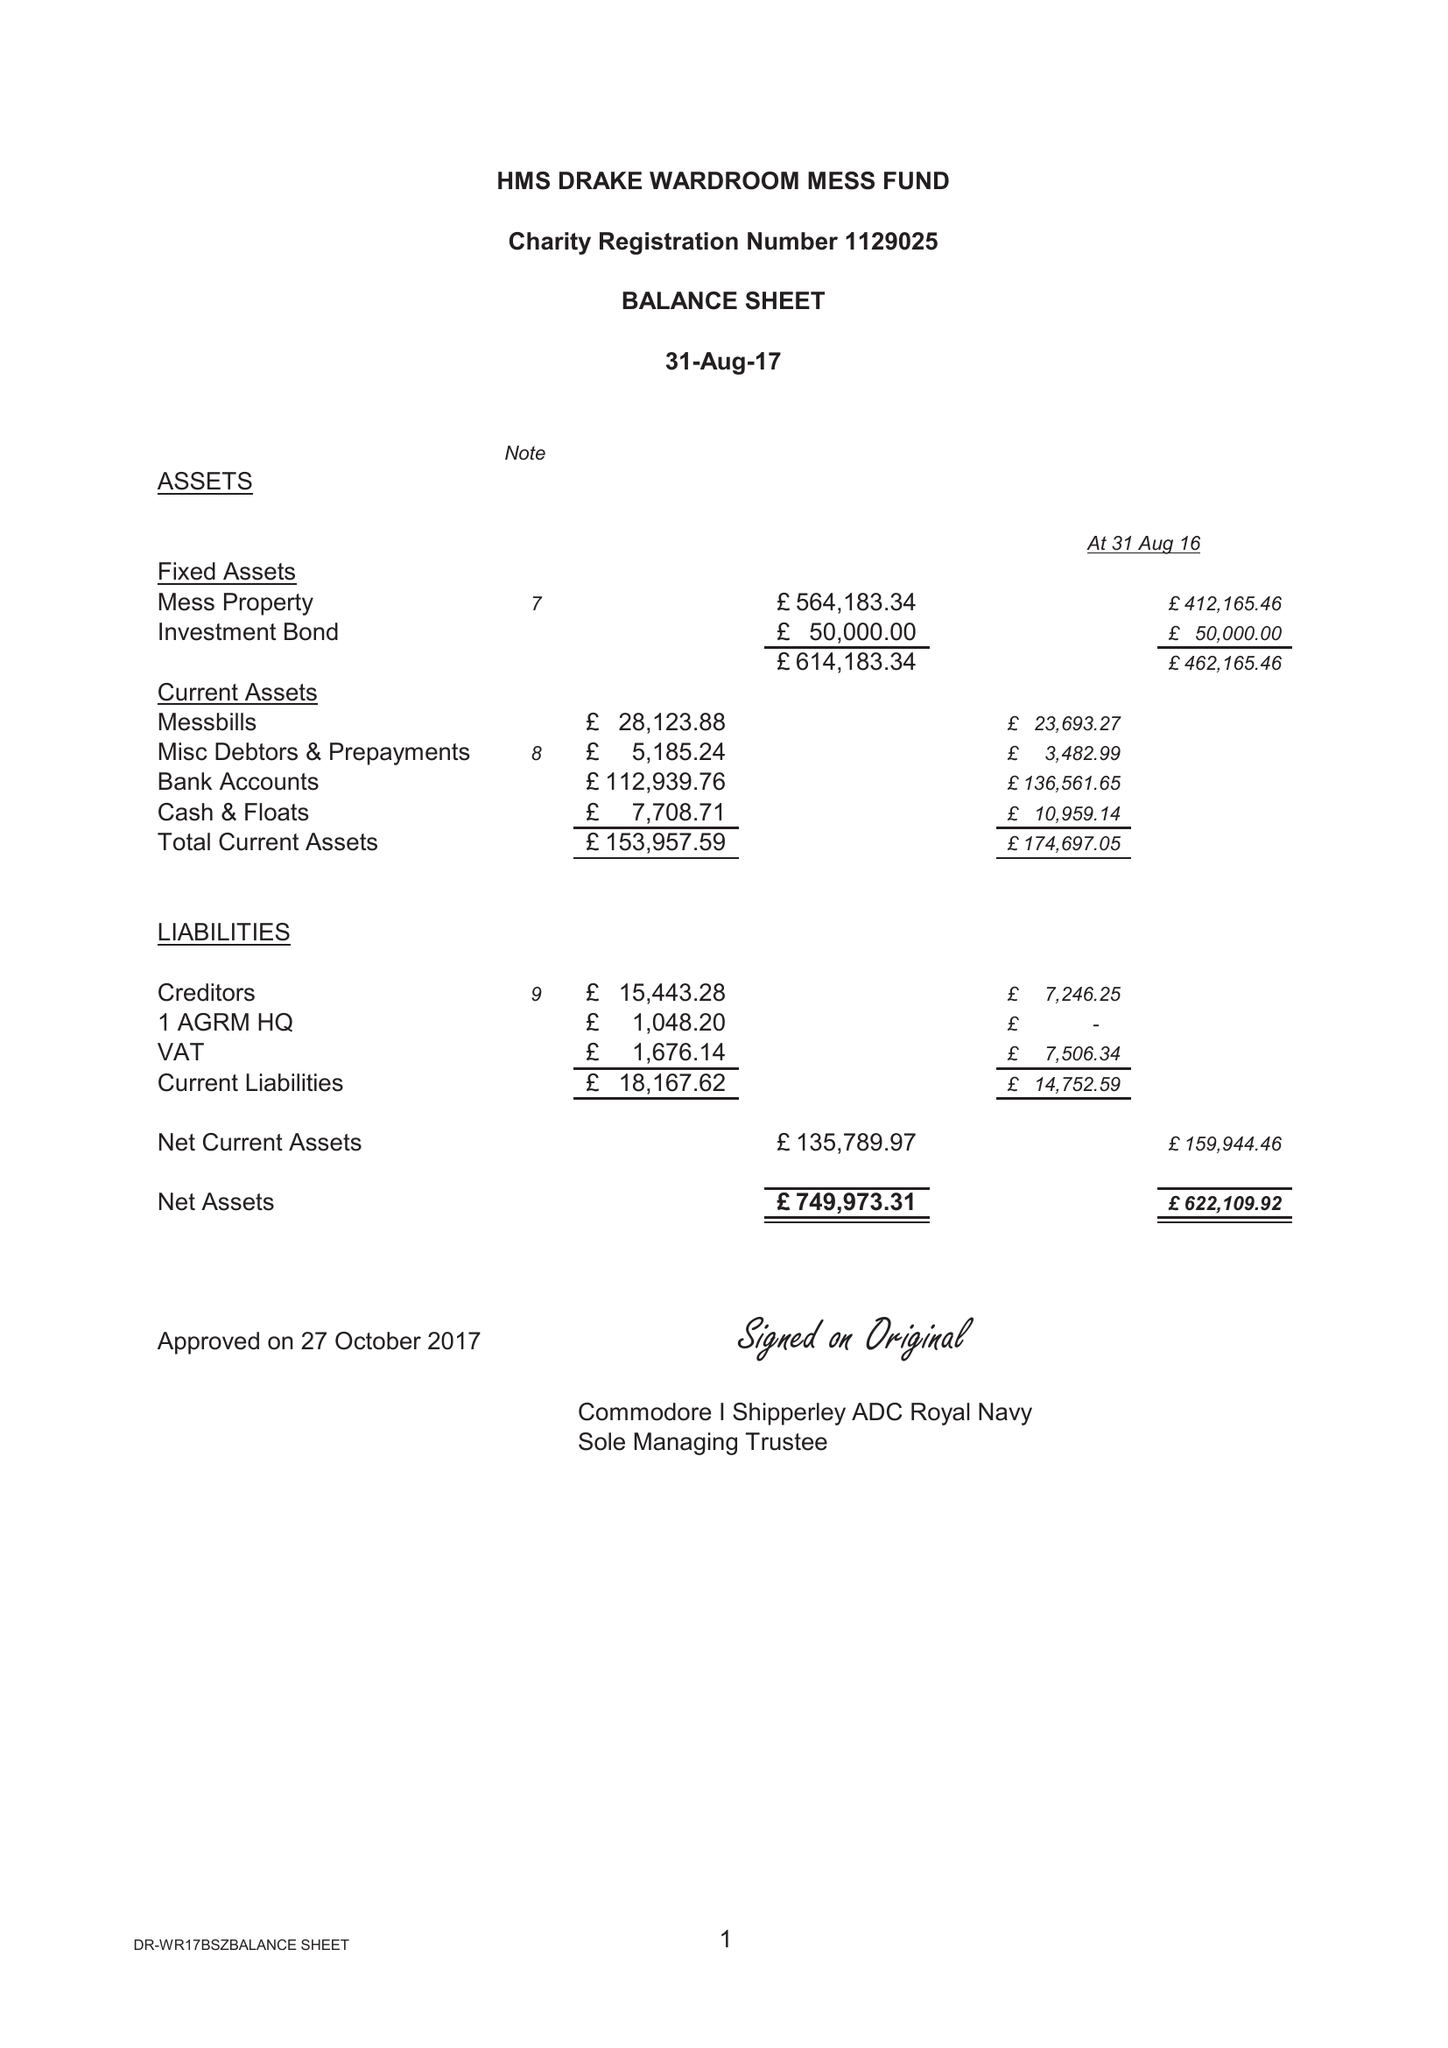What is the value for the address__postcode?
Answer the question using a single word or phrase. PL2 2BG 